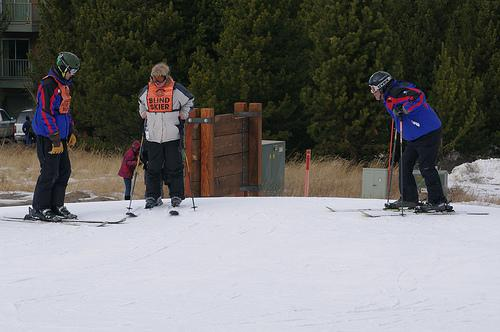Question: what is behind the picture?
Choices:
A. Mountains.
B. Trees.
C. A barn.
D. A garden.
Answer with the letter. Answer: B Question: what is in the ground?
Choices:
A. Snow.
B. Grass.
C. Rocks.
D. Sand.
Answer with the letter. Answer: A Question: what are the people doing?
Choices:
A. Talking.
B. Watching a game.
C. Planting flowers.
D. Skiting.
Answer with the letter. Answer: D Question: what is the color of the trees?
Choices:
A. Green.
B. Brown.
C. White.
D. Black.
Answer with the letter. Answer: A Question: where is the picture taken?
Choices:
A. At a ski resort.
B. At the fireworks show.
C. On a ranch.
D. Before a concert.
Answer with the letter. Answer: A 